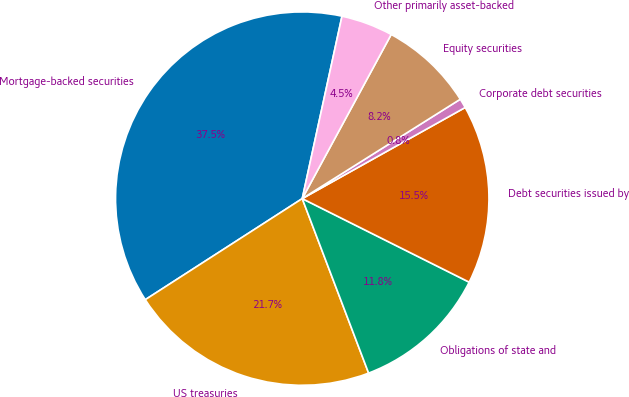Convert chart to OTSL. <chart><loc_0><loc_0><loc_500><loc_500><pie_chart><fcel>Mortgage-backed securities<fcel>US treasuries<fcel>Obligations of state and<fcel>Debt securities issued by<fcel>Corporate debt securities<fcel>Equity securities<fcel>Other primarily asset-backed<nl><fcel>37.52%<fcel>21.68%<fcel>11.83%<fcel>15.5%<fcel>0.82%<fcel>8.16%<fcel>4.49%<nl></chart> 